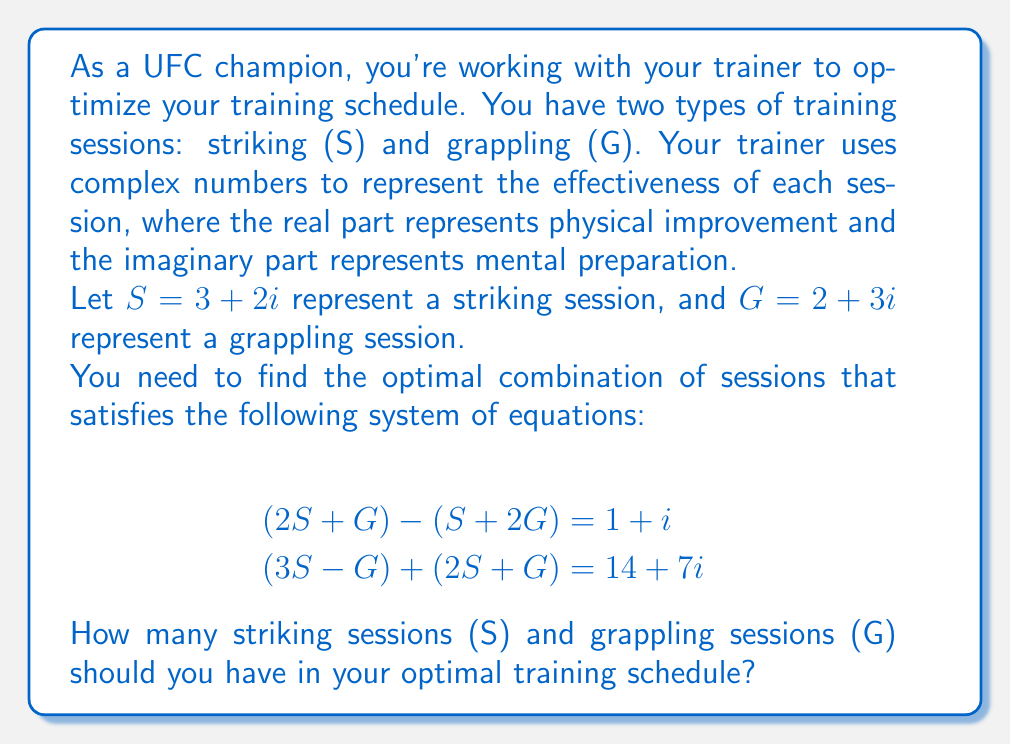Can you solve this math problem? Let's solve this system of equations step by step:

1) First, let's substitute the values of S and G into the equations:

   $S = 3 + 2i$
   $G = 2 + 3i$

2) For the first equation: $(2S + G) - (S + 2G) = 1 + i$

   Left side: $[2(3+2i) + (2+3i)] - [(3+2i) + 2(2+3i)]$
            $= [(6+4i) + (2+3i)] - [(3+2i) + (4+6i)]$
            $= (8+7i) - (7+8i)$
            $= 1 - i$

   This matches the right side $(1+i)$, so this equation is satisfied.

3) For the second equation: $(3S - G) + (2S + G) = 14 + 7i$

   Left side: $[3(3+2i) - (2+3i)] + [2(3+2i) + (2+3i)]$
            $= [(9+6i) - (2+3i)] + [(6+4i) + (2+3i)]$
            $= (7+3i) + (8+7i)$
            $= 15 + 10i$

   This doesn't match the right side $(14+7i)$, so we need to solve for the number of sessions.

4) Let's say we need $x$ striking sessions and $y$ grappling sessions. We can set up a new system of equations:

   $x(3+2i) + y(2+3i) = 14 + 7i$

   Equating real and imaginary parts:
   $3x + 2y = 14$
   $2x + 3y = 7$

5) We can solve this system using substitution or elimination:
   
   Multiplying the second equation by 3 and the first by 2:
   $9x + 6y = 42$
   $4x + 6y = 14$

   Subtracting the second from the first:
   $5x = 28$
   $x = \frac{28}{5} = 5.6$

   Substituting back into $2x + 3y = 7$:
   $2(5.6) + 3y = 7$
   $11.2 + 3y = 7$
   $3y = -4.2$
   $y = -1.4$

6) Since we can't have fractional or negative training sessions, we need to round to the nearest whole numbers:

   $x = 6$ striking sessions
   $y = 0$ grappling sessions
Answer: The optimal training schedule consists of 6 striking sessions (S) and 0 grappling sessions (G). 